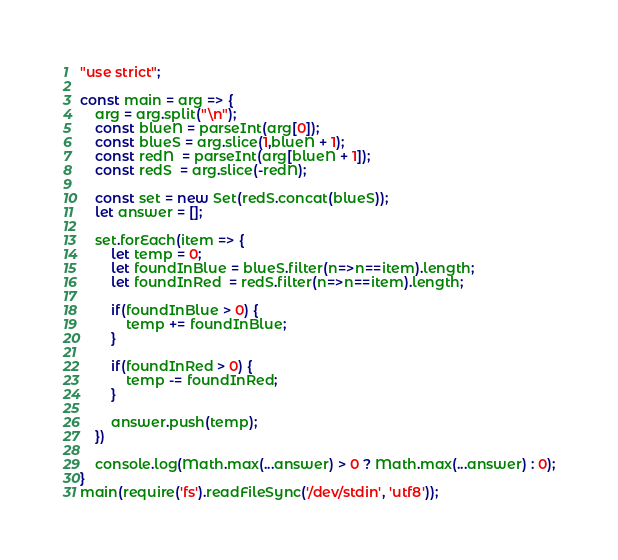Convert code to text. <code><loc_0><loc_0><loc_500><loc_500><_JavaScript_>"use strict";
    
const main = arg => {
    arg = arg.split("\n");
    const blueN = parseInt(arg[0]);
    const blueS = arg.slice(1,blueN + 1);
    const redN  = parseInt(arg[blueN + 1]);
    const redS  = arg.slice(-redN);
    
    const set = new Set(redS.concat(blueS));
    let answer = [];

    set.forEach(item => {
        let temp = 0;
        let foundInBlue = blueS.filter(n=>n==item).length;
        let foundInRed  = redS.filter(n=>n==item).length;
        
        if(foundInBlue > 0) {
            temp += foundInBlue;
        }
        
        if(foundInRed > 0) {
            temp -= foundInRed;
        }
        
        answer.push(temp);
    })
    
    console.log(Math.max(...answer) > 0 ? Math.max(...answer) : 0);
}
main(require('fs').readFileSync('/dev/stdin', 'utf8'));
</code> 